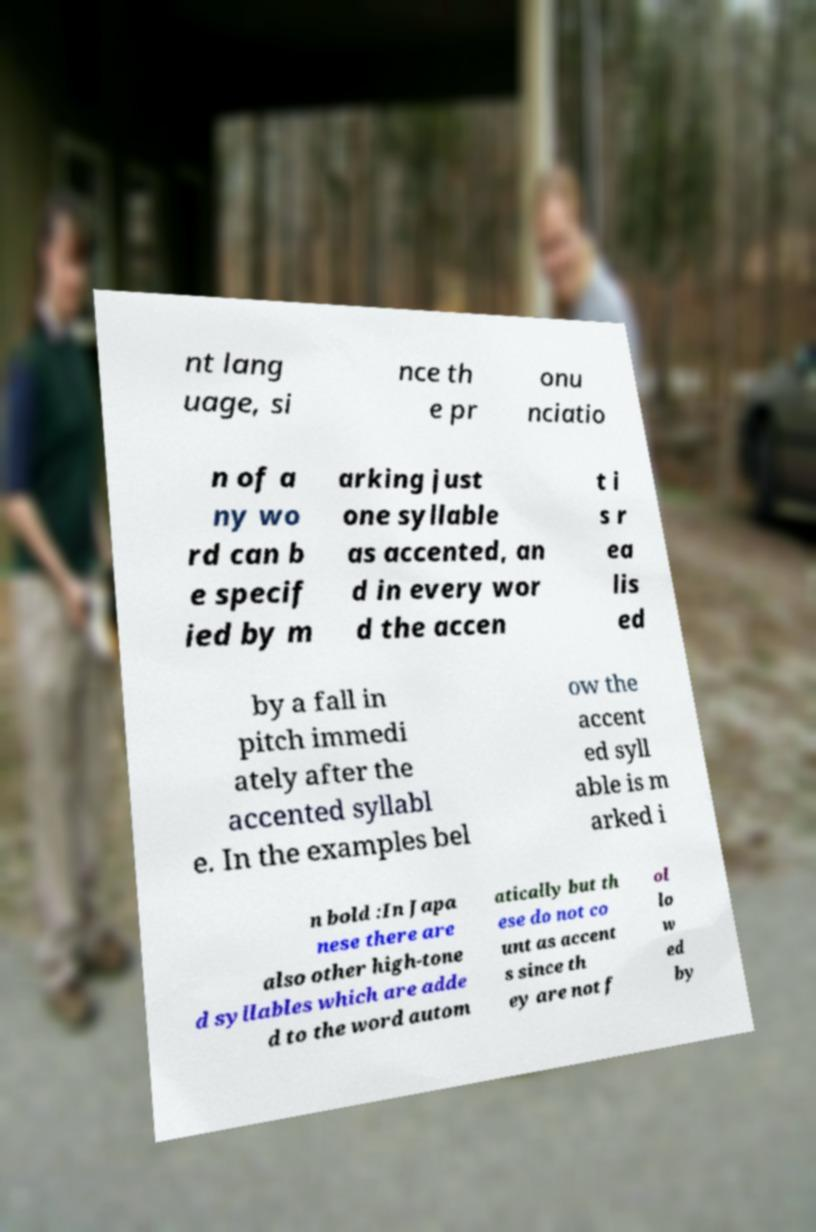There's text embedded in this image that I need extracted. Can you transcribe it verbatim? nt lang uage, si nce th e pr onu nciatio n of a ny wo rd can b e specif ied by m arking just one syllable as accented, an d in every wor d the accen t i s r ea lis ed by a fall in pitch immedi ately after the accented syllabl e. In the examples bel ow the accent ed syll able is m arked i n bold :In Japa nese there are also other high-tone d syllables which are adde d to the word autom atically but th ese do not co unt as accent s since th ey are not f ol lo w ed by 